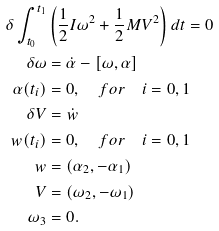Convert formula to latex. <formula><loc_0><loc_0><loc_500><loc_500>\delta \int _ { t _ { 0 } } ^ { t _ { 1 } } & \left ( \frac { 1 } { 2 } I \omega ^ { 2 } + \frac { 1 } { 2 } M V ^ { 2 } \right ) d t = 0 \\ \delta \omega & = \dot { \alpha } - [ \omega , \alpha ] \\ \alpha ( t _ { i } ) & = 0 , \quad f o r \quad i = 0 , 1 \\ \delta V & = \dot { w } \\ w ( t _ { i } ) & = 0 , \quad f o r \quad i = 0 , 1 \\ w & = ( \alpha _ { 2 } , - \alpha _ { 1 } ) \\ V & = ( \omega _ { 2 } , - \omega _ { 1 } ) \\ \omega _ { 3 } & = 0 .</formula> 